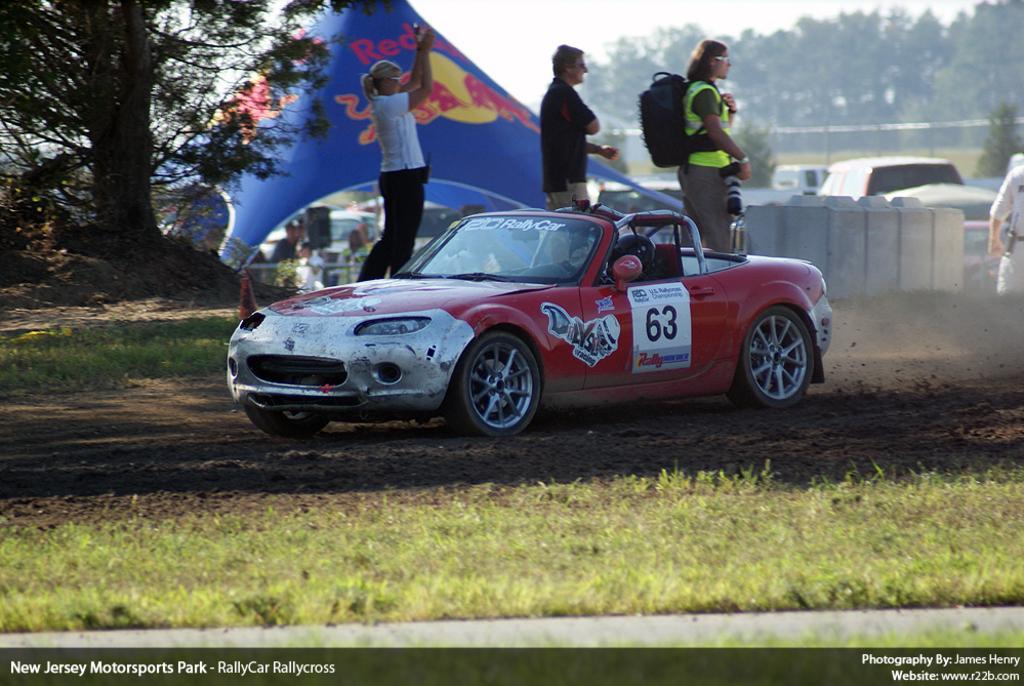In one or two sentences, can you explain what this image depicts? In this image we can see a tent, trees, sky, motor vehicles, persons standing on the ground, trees and poles. 